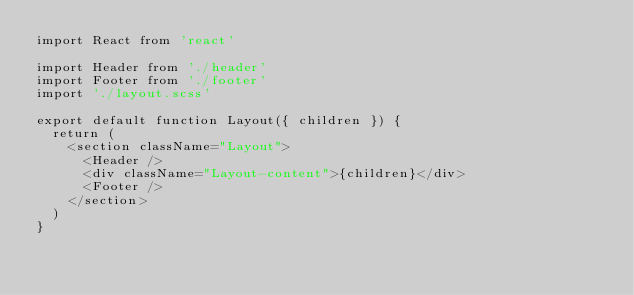Convert code to text. <code><loc_0><loc_0><loc_500><loc_500><_JavaScript_>import React from 'react'

import Header from './header'
import Footer from './footer'
import './layout.scss'

export default function Layout({ children }) {
  return (
    <section className="Layout">
      <Header />
      <div className="Layout-content">{children}</div>
      <Footer />
    </section>
  )
}
</code> 